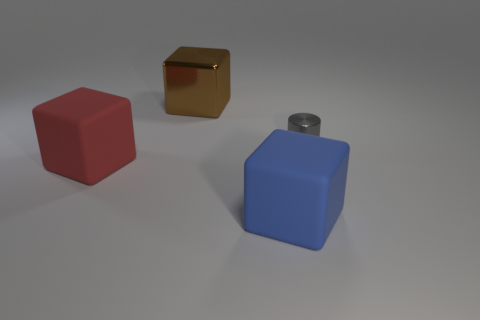Add 2 tiny gray rubber cylinders. How many objects exist? 6 Subtract all cylinders. How many objects are left? 3 Subtract 0 green cylinders. How many objects are left? 4 Subtract all brown blocks. Subtract all big red objects. How many objects are left? 2 Add 3 large red cubes. How many large red cubes are left? 4 Add 3 tiny gray metal cylinders. How many tiny gray metal cylinders exist? 4 